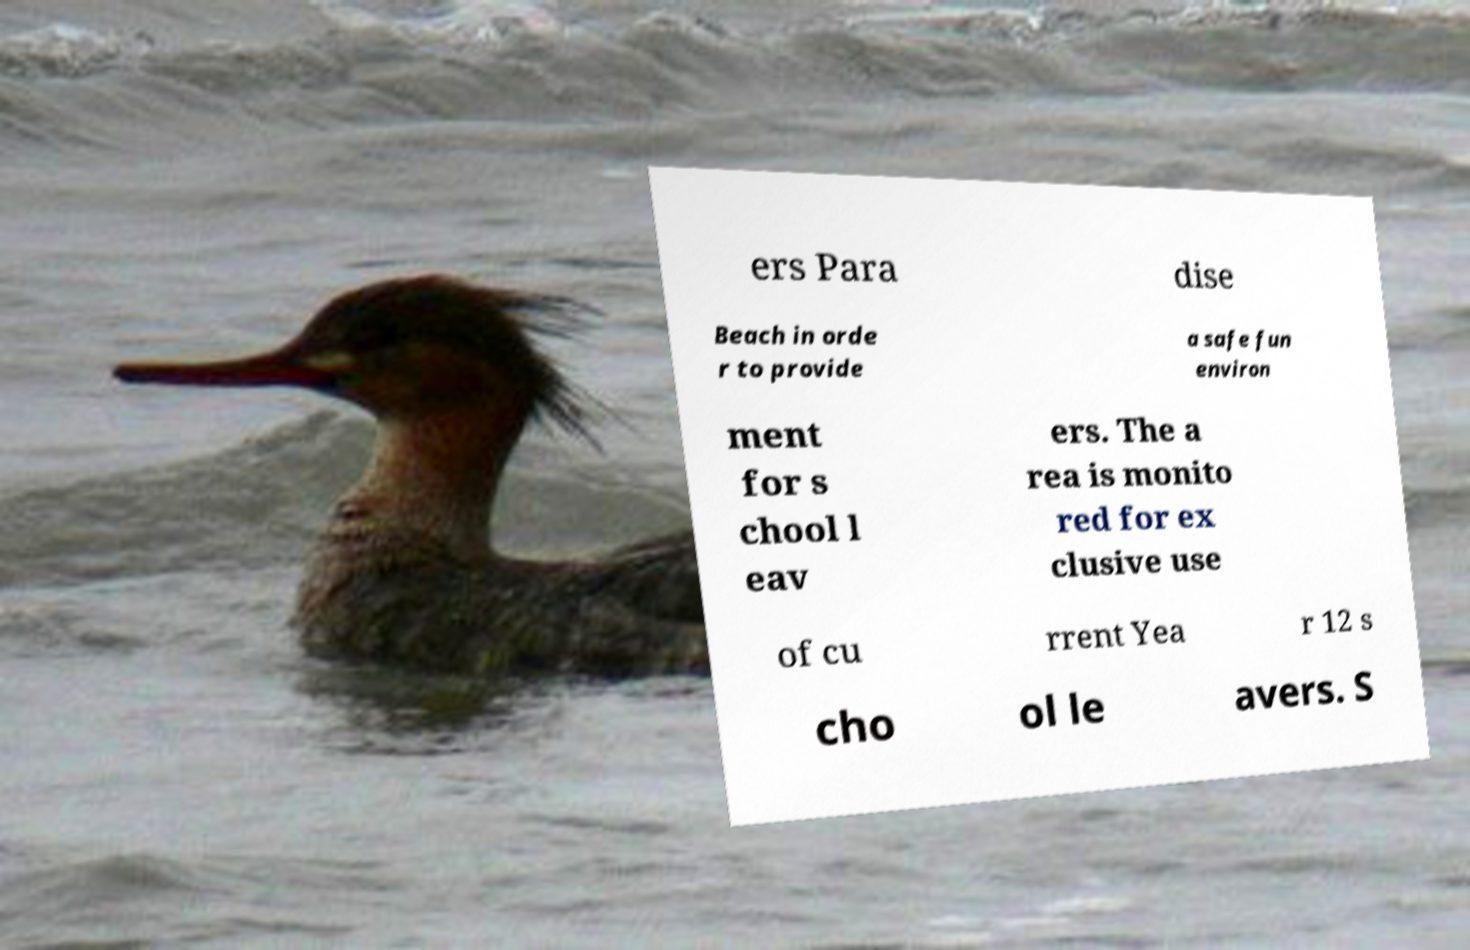Please read and relay the text visible in this image. What does it say? ers Para dise Beach in orde r to provide a safe fun environ ment for s chool l eav ers. The a rea is monito red for ex clusive use of cu rrent Yea r 12 s cho ol le avers. S 